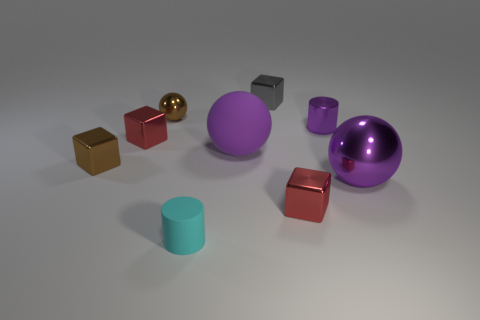There is a cylinder left of the tiny red metallic thing in front of the brown object in front of the brown shiny ball; what is its color?
Offer a terse response. Cyan. There is another large object that is the same shape as the large shiny object; what material is it?
Provide a short and direct response. Rubber. What number of cubes have the same size as the rubber cylinder?
Provide a succinct answer. 4. How many small things are there?
Keep it short and to the point. 7. Does the cyan object have the same material as the purple ball that is on the left side of the large metal object?
Make the answer very short. Yes. What number of purple objects are matte objects or large objects?
Make the answer very short. 2. What size is the gray cube that is made of the same material as the brown sphere?
Make the answer very short. Small. What number of tiny purple objects have the same shape as the small cyan matte object?
Make the answer very short. 1. Is the number of small purple cylinders that are to the right of the large purple shiny thing greater than the number of red metal things that are right of the cyan matte cylinder?
Provide a short and direct response. No. There is a rubber cylinder; is it the same color as the ball that is to the left of the cyan matte thing?
Offer a terse response. No. 